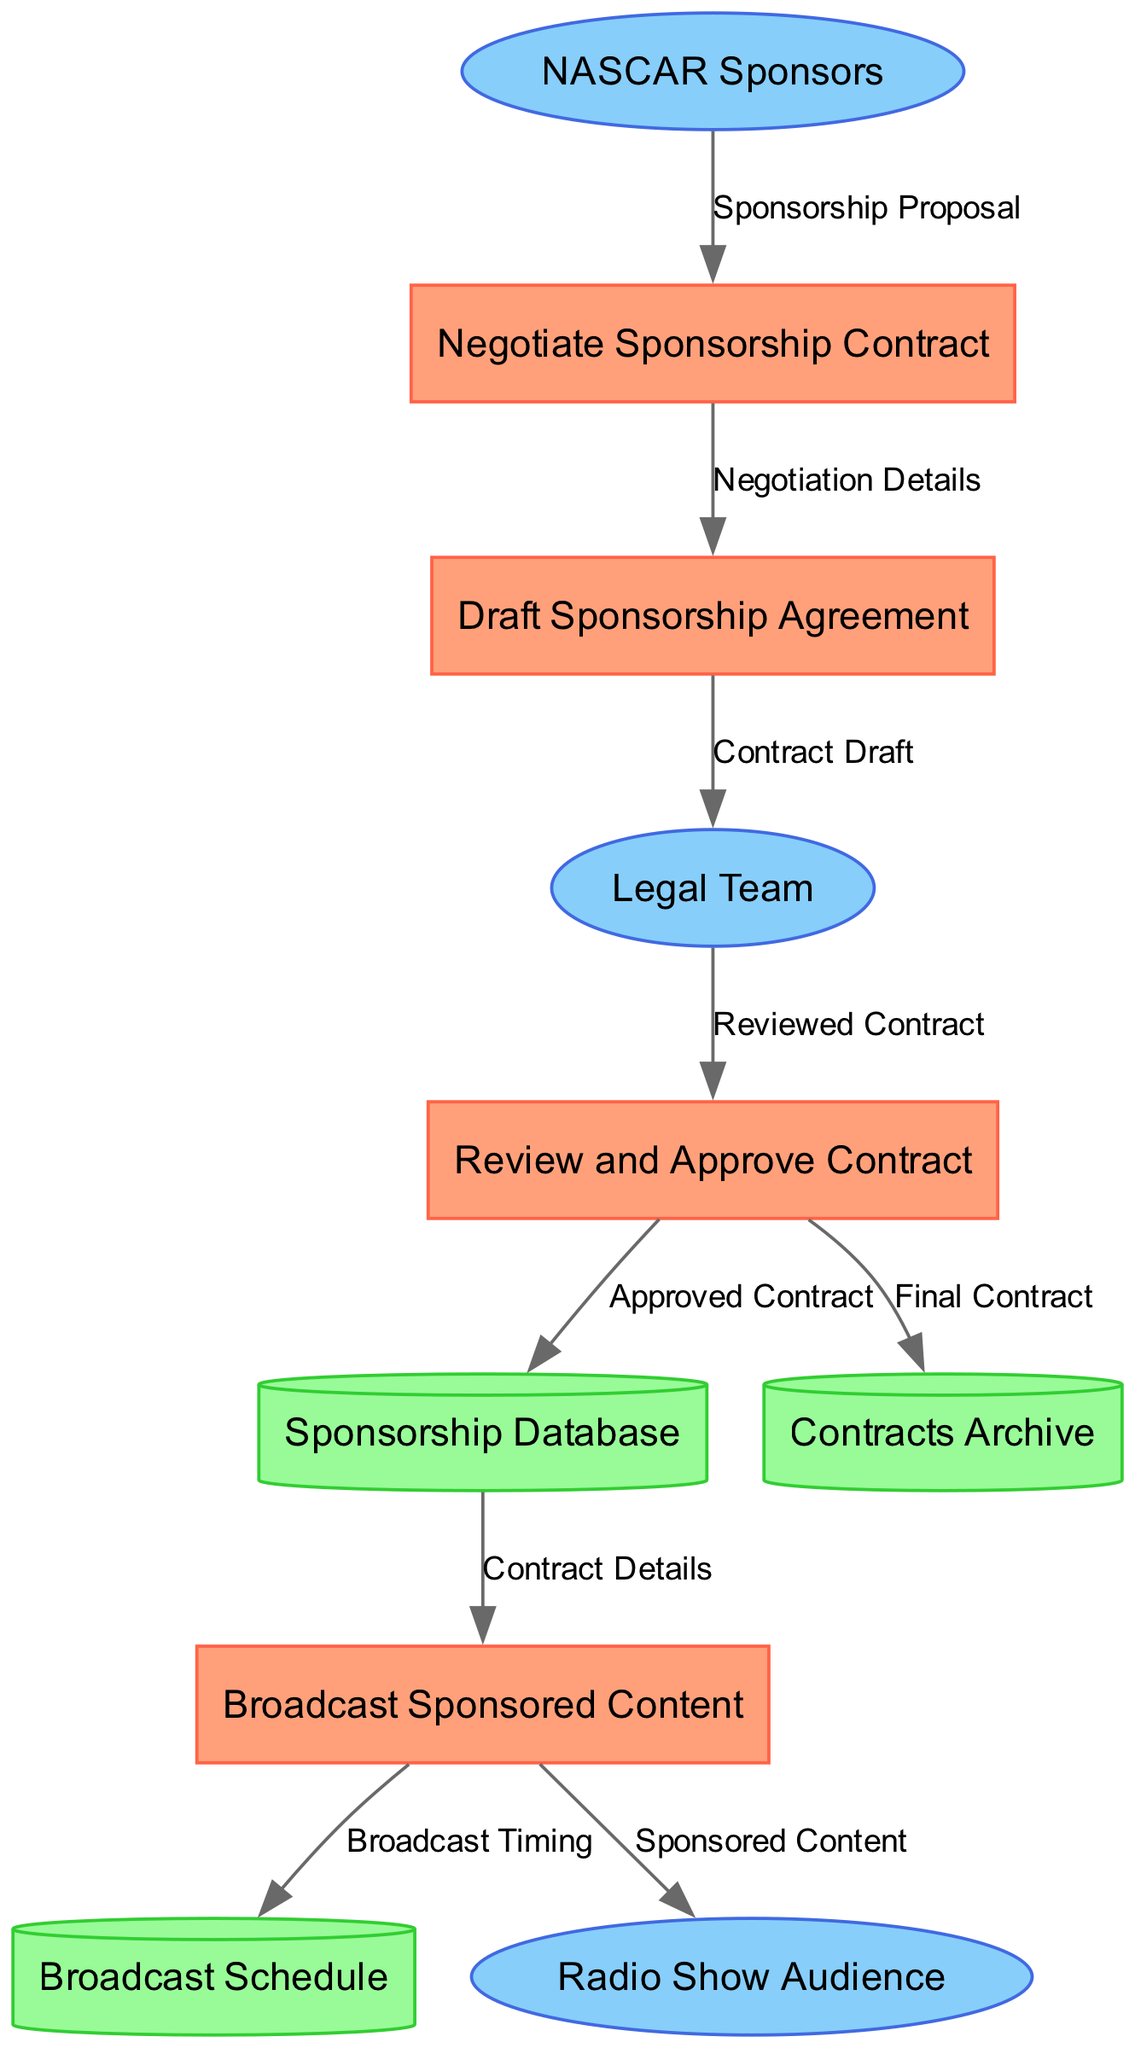What is the first process in the diagram? The first process listed in the diagram is "Negotiate Sponsorship Contract," which is given as the first item in the processes section.
Answer: Negotiate Sponsorship Contract How many external entities are represented in the diagram? The diagram lists three external entities, as indicated in the external entities section of the data.
Answer: 3 Which data store is used to archive final contracts? The data flow indicates that the "Contracts Archive" data store is where the "Final Contract" is sent after approval, as outlined in the relationship between processes and data stores.
Answer: Contracts Archive What document does the Legal Team receive from the Draft Sponsorship Agreement? The diagram specifies that the "Draft Sponsorship Agreement" sends a "Contract Draft" to the Legal Team, as per the data flow between these two elements.
Answer: Contract Draft What is the final output that is broadcasted to the Radio Show Audience? The output to the Radio Show Audience comes from the "Broadcast Sponsored Content" process, which sends out "Sponsored Content" according to the diagram.
Answer: Sponsored Content Which process leads to the addition of an approved contract to the Sponsorship Database? The "Review and Approve Contract" process is responsible for sending the "Approved Contract" to the "Sponsorship Database," as shown in the flow of information.
Answer: Review and Approve Contract What type of document is stored in the Broadcast Schedule? The diagram indicates that the "Broadcast Sponsored Content" process sends "Broadcast Timing" to the "Broadcast Schedule," thus identifying the type of document stored there.
Answer: Broadcast Timing What initiates the contract negotiation process? The process is initiated by receiving a "Sponsorship Proposal" from the "NASCAR Sponsors," which starts the "Negotiate Sponsorship Contract" process according to the diagram's flow.
Answer: Sponsorship Proposal What is the relationship between the Review and Approve Contract process and the Contracts Archive? The "Review and Approve Contract" process sends a "Final Contract" to the "Contracts Archive," indicating a direct relationship in terms of stored output.
Answer: Final Contract 